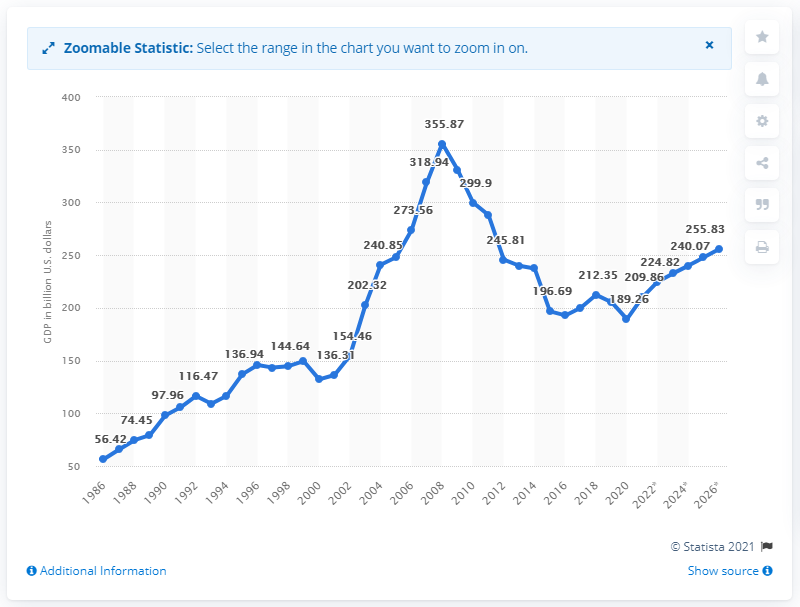Give some essential details in this illustration. In 2020, the Gross Domestic Product (GDP) of Greece was 189.26 billion dollars. 